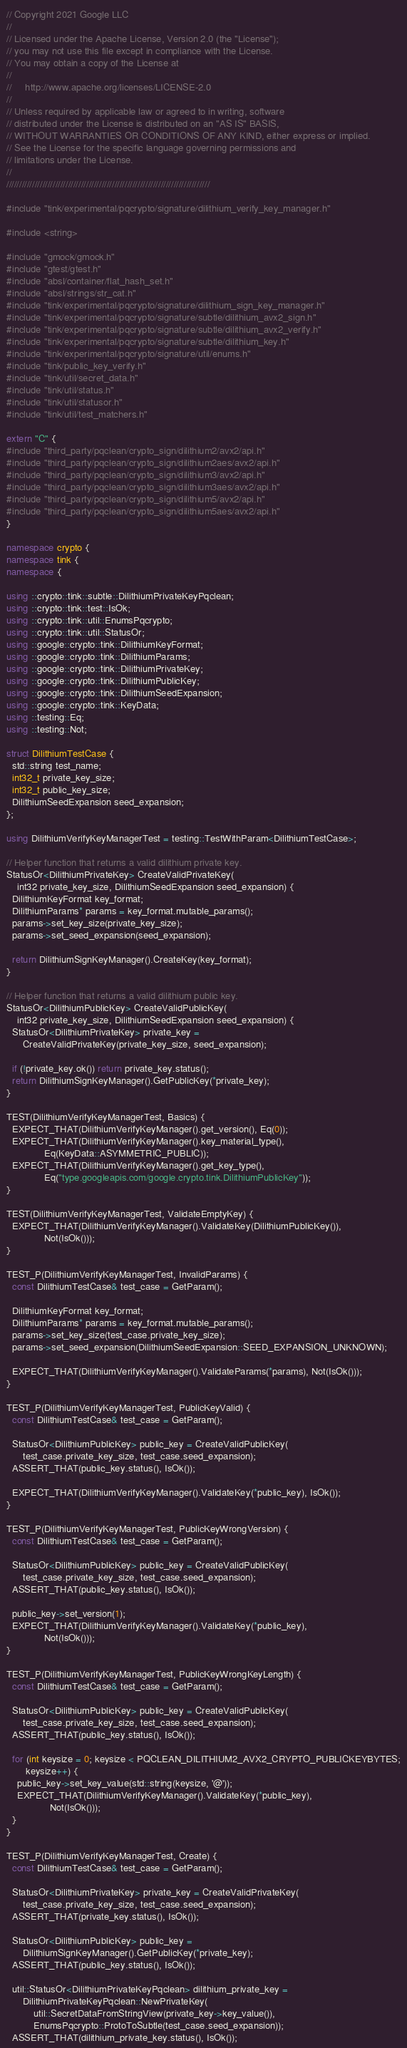Convert code to text. <code><loc_0><loc_0><loc_500><loc_500><_C++_>// Copyright 2021 Google LLC
//
// Licensed under the Apache License, Version 2.0 (the "License");
// you may not use this file except in compliance with the License.
// You may obtain a copy of the License at
//
//     http://www.apache.org/licenses/LICENSE-2.0
//
// Unless required by applicable law or agreed to in writing, software
// distributed under the License is distributed on an "AS IS" BASIS,
// WITHOUT WARRANTIES OR CONDITIONS OF ANY KIND, either express or implied.
// See the License for the specific language governing permissions and
// limitations under the License.
//
///////////////////////////////////////////////////////////////////////////////

#include "tink/experimental/pqcrypto/signature/dilithium_verify_key_manager.h"

#include <string>

#include "gmock/gmock.h"
#include "gtest/gtest.h"
#include "absl/container/flat_hash_set.h"
#include "absl/strings/str_cat.h"
#include "tink/experimental/pqcrypto/signature/dilithium_sign_key_manager.h"
#include "tink/experimental/pqcrypto/signature/subtle/dilithium_avx2_sign.h"
#include "tink/experimental/pqcrypto/signature/subtle/dilithium_avx2_verify.h"
#include "tink/experimental/pqcrypto/signature/subtle/dilithium_key.h"
#include "tink/experimental/pqcrypto/signature/util/enums.h"
#include "tink/public_key_verify.h"
#include "tink/util/secret_data.h"
#include "tink/util/status.h"
#include "tink/util/statusor.h"
#include "tink/util/test_matchers.h"

extern "C" {
#include "third_party/pqclean/crypto_sign/dilithium2/avx2/api.h"
#include "third_party/pqclean/crypto_sign/dilithium2aes/avx2/api.h"
#include "third_party/pqclean/crypto_sign/dilithium3/avx2/api.h"
#include "third_party/pqclean/crypto_sign/dilithium3aes/avx2/api.h"
#include "third_party/pqclean/crypto_sign/dilithium5/avx2/api.h"
#include "third_party/pqclean/crypto_sign/dilithium5aes/avx2/api.h"
}

namespace crypto {
namespace tink {
namespace {

using ::crypto::tink::subtle::DilithiumPrivateKeyPqclean;
using ::crypto::tink::test::IsOk;
using ::crypto::tink::util::EnumsPqcrypto;
using ::crypto::tink::util::StatusOr;
using ::google::crypto::tink::DilithiumKeyFormat;
using ::google::crypto::tink::DilithiumParams;
using ::google::crypto::tink::DilithiumPrivateKey;
using ::google::crypto::tink::DilithiumPublicKey;
using ::google::crypto::tink::DilithiumSeedExpansion;
using ::google::crypto::tink::KeyData;
using ::testing::Eq;
using ::testing::Not;

struct DilithiumTestCase {
  std::string test_name;
  int32_t private_key_size;
  int32_t public_key_size;
  DilithiumSeedExpansion seed_expansion;
};

using DilithiumVerifyKeyManagerTest = testing::TestWithParam<DilithiumTestCase>;

// Helper function that returns a valid dilithium private key.
StatusOr<DilithiumPrivateKey> CreateValidPrivateKey(
    int32 private_key_size, DilithiumSeedExpansion seed_expansion) {
  DilithiumKeyFormat key_format;
  DilithiumParams* params = key_format.mutable_params();
  params->set_key_size(private_key_size);
  params->set_seed_expansion(seed_expansion);

  return DilithiumSignKeyManager().CreateKey(key_format);
}

// Helper function that returns a valid dilithium public key.
StatusOr<DilithiumPublicKey> CreateValidPublicKey(
    int32 private_key_size, DilithiumSeedExpansion seed_expansion) {
  StatusOr<DilithiumPrivateKey> private_key =
      CreateValidPrivateKey(private_key_size, seed_expansion);

  if (!private_key.ok()) return private_key.status();
  return DilithiumSignKeyManager().GetPublicKey(*private_key);
}

TEST(DilithiumVerifyKeyManagerTest, Basics) {
  EXPECT_THAT(DilithiumVerifyKeyManager().get_version(), Eq(0));
  EXPECT_THAT(DilithiumVerifyKeyManager().key_material_type(),
              Eq(KeyData::ASYMMETRIC_PUBLIC));
  EXPECT_THAT(DilithiumVerifyKeyManager().get_key_type(),
              Eq("type.googleapis.com/google.crypto.tink.DilithiumPublicKey"));
}

TEST(DilithiumVerifyKeyManagerTest, ValidateEmptyKey) {
  EXPECT_THAT(DilithiumVerifyKeyManager().ValidateKey(DilithiumPublicKey()),
              Not(IsOk()));
}

TEST_P(DilithiumVerifyKeyManagerTest, InvalidParams) {
  const DilithiumTestCase& test_case = GetParam();

  DilithiumKeyFormat key_format;
  DilithiumParams* params = key_format.mutable_params();
  params->set_key_size(test_case.private_key_size);
  params->set_seed_expansion(DilithiumSeedExpansion::SEED_EXPANSION_UNKNOWN);

  EXPECT_THAT(DilithiumVerifyKeyManager().ValidateParams(*params), Not(IsOk()));
}

TEST_P(DilithiumVerifyKeyManagerTest, PublicKeyValid) {
  const DilithiumTestCase& test_case = GetParam();

  StatusOr<DilithiumPublicKey> public_key = CreateValidPublicKey(
      test_case.private_key_size, test_case.seed_expansion);
  ASSERT_THAT(public_key.status(), IsOk());

  EXPECT_THAT(DilithiumVerifyKeyManager().ValidateKey(*public_key), IsOk());
}

TEST_P(DilithiumVerifyKeyManagerTest, PublicKeyWrongVersion) {
  const DilithiumTestCase& test_case = GetParam();

  StatusOr<DilithiumPublicKey> public_key = CreateValidPublicKey(
      test_case.private_key_size, test_case.seed_expansion);
  ASSERT_THAT(public_key.status(), IsOk());

  public_key->set_version(1);
  EXPECT_THAT(DilithiumVerifyKeyManager().ValidateKey(*public_key),
              Not(IsOk()));
}

TEST_P(DilithiumVerifyKeyManagerTest, PublicKeyWrongKeyLength) {
  const DilithiumTestCase& test_case = GetParam();

  StatusOr<DilithiumPublicKey> public_key = CreateValidPublicKey(
      test_case.private_key_size, test_case.seed_expansion);
  ASSERT_THAT(public_key.status(), IsOk());

  for (int keysize = 0; keysize < PQCLEAN_DILITHIUM2_AVX2_CRYPTO_PUBLICKEYBYTES;
       keysize++) {
    public_key->set_key_value(std::string(keysize, '@'));
    EXPECT_THAT(DilithiumVerifyKeyManager().ValidateKey(*public_key),
                Not(IsOk()));
  }
}

TEST_P(DilithiumVerifyKeyManagerTest, Create) {
  const DilithiumTestCase& test_case = GetParam();

  StatusOr<DilithiumPrivateKey> private_key = CreateValidPrivateKey(
      test_case.private_key_size, test_case.seed_expansion);
  ASSERT_THAT(private_key.status(), IsOk());

  StatusOr<DilithiumPublicKey> public_key =
      DilithiumSignKeyManager().GetPublicKey(*private_key);
  ASSERT_THAT(public_key.status(), IsOk());

  util::StatusOr<DilithiumPrivateKeyPqclean> dilithium_private_key =
      DilithiumPrivateKeyPqclean::NewPrivateKey(
          util::SecretDataFromStringView(private_key->key_value()),
          EnumsPqcrypto::ProtoToSubtle(test_case.seed_expansion));
  ASSERT_THAT(dilithium_private_key.status(), IsOk());
</code> 